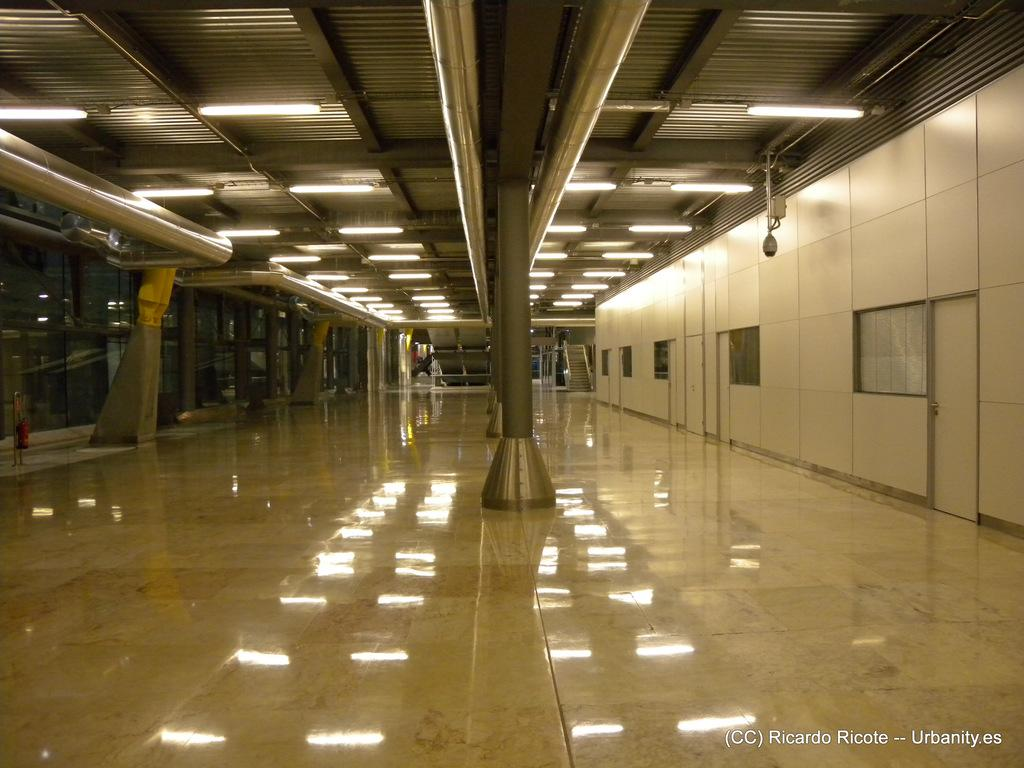What type of space is depicted in the image? There is a big hall in the image. What can be seen in the roof of the hall? There are lights in the roof of the hall. What architectural feature is present in the middle of the hall? There is a pillar in the middle of the hall. How much money is being exchanged during the event in the image? There is no event or money exchange depicted in the image; it only shows a big hall with lights and a pillar. 